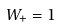<formula> <loc_0><loc_0><loc_500><loc_500>W _ { + } = 1</formula> 